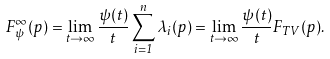Convert formula to latex. <formula><loc_0><loc_0><loc_500><loc_500>F _ { \psi } ^ { \infty } ( p ) = \lim _ { t \rightarrow \infty } \frac { \psi ( t ) } { t } \sum _ { i = 1 } ^ { n } \lambda _ { i } ( p ) = \lim _ { t \rightarrow \infty } \frac { \psi ( t ) } { t } F _ { T V } ( p ) .</formula> 